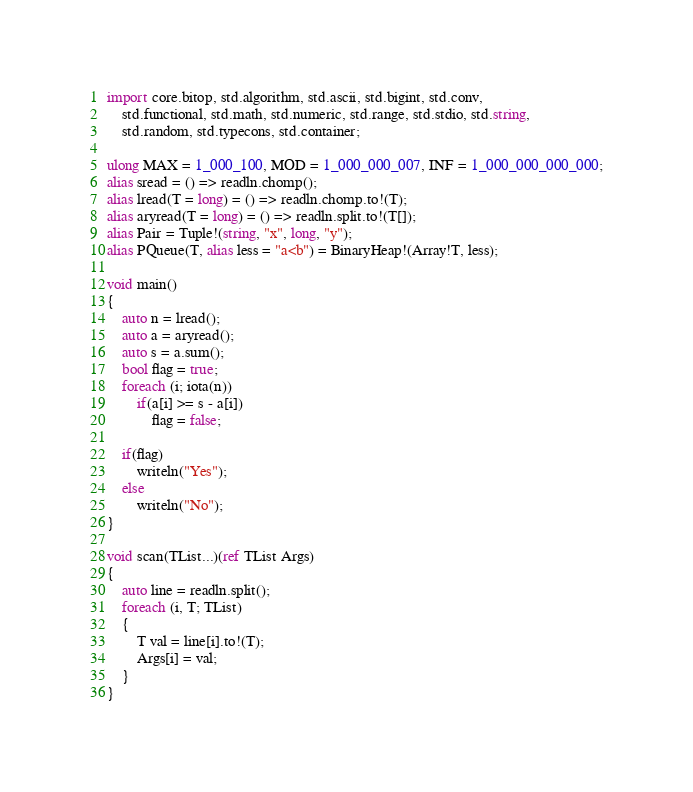<code> <loc_0><loc_0><loc_500><loc_500><_D_>import core.bitop, std.algorithm, std.ascii, std.bigint, std.conv,
    std.functional, std.math, std.numeric, std.range, std.stdio, std.string,
    std.random, std.typecons, std.container;

ulong MAX = 1_000_100, MOD = 1_000_000_007, INF = 1_000_000_000_000;
alias sread = () => readln.chomp();
alias lread(T = long) = () => readln.chomp.to!(T);
alias aryread(T = long) = () => readln.split.to!(T[]);
alias Pair = Tuple!(string, "x", long, "y");
alias PQueue(T, alias less = "a<b") = BinaryHeap!(Array!T, less);

void main()
{
    auto n = lread();
    auto a = aryread();
    auto s = a.sum();
    bool flag = true;
    foreach (i; iota(n))
        if(a[i] >= s - a[i])
            flag = false;

    if(flag)
        writeln("Yes");
    else
        writeln("No");
}

void scan(TList...)(ref TList Args)
{
    auto line = readln.split();
    foreach (i, T; TList)
    {
        T val = line[i].to!(T);
        Args[i] = val;
    }
}
</code> 